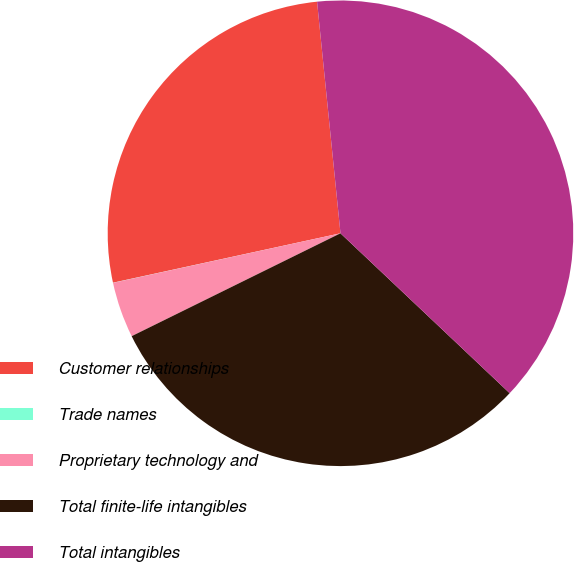Convert chart. <chart><loc_0><loc_0><loc_500><loc_500><pie_chart><fcel>Customer relationships<fcel>Trade names<fcel>Proprietary technology and<fcel>Total finite-life intangibles<fcel>Total intangibles<nl><fcel>26.8%<fcel>0.01%<fcel>3.87%<fcel>30.66%<fcel>38.65%<nl></chart> 